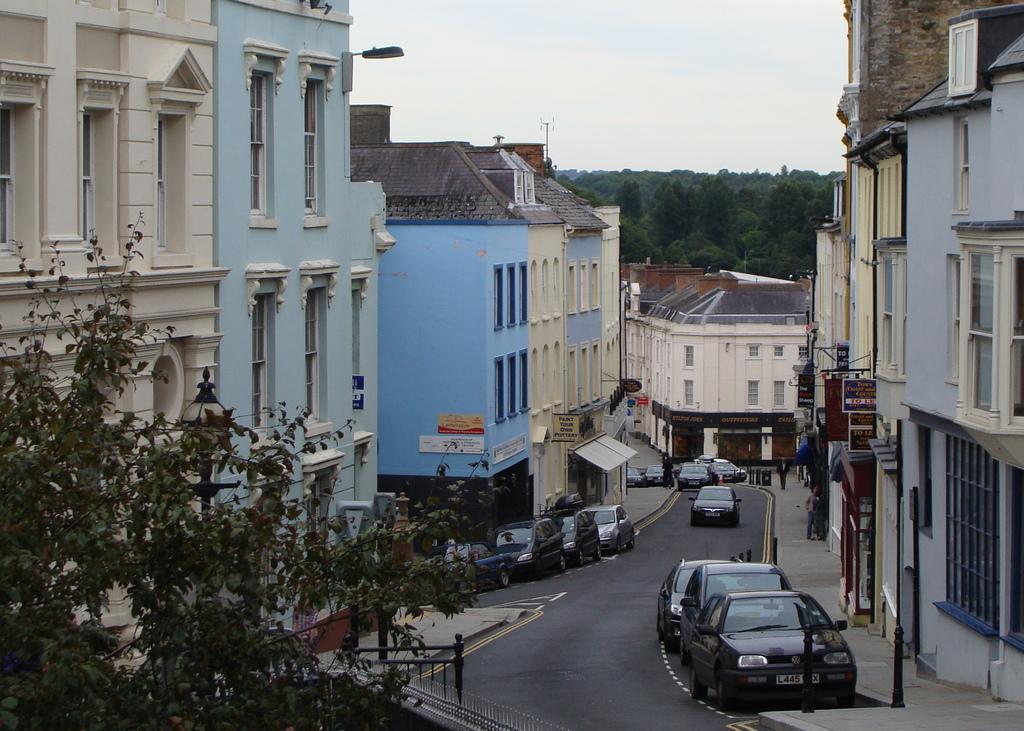Describe this image in one or two sentences. In this image at the bottom, there are cars and road. On the right there are buildings and trees. On the left there are buildings, windows, light and sky. 